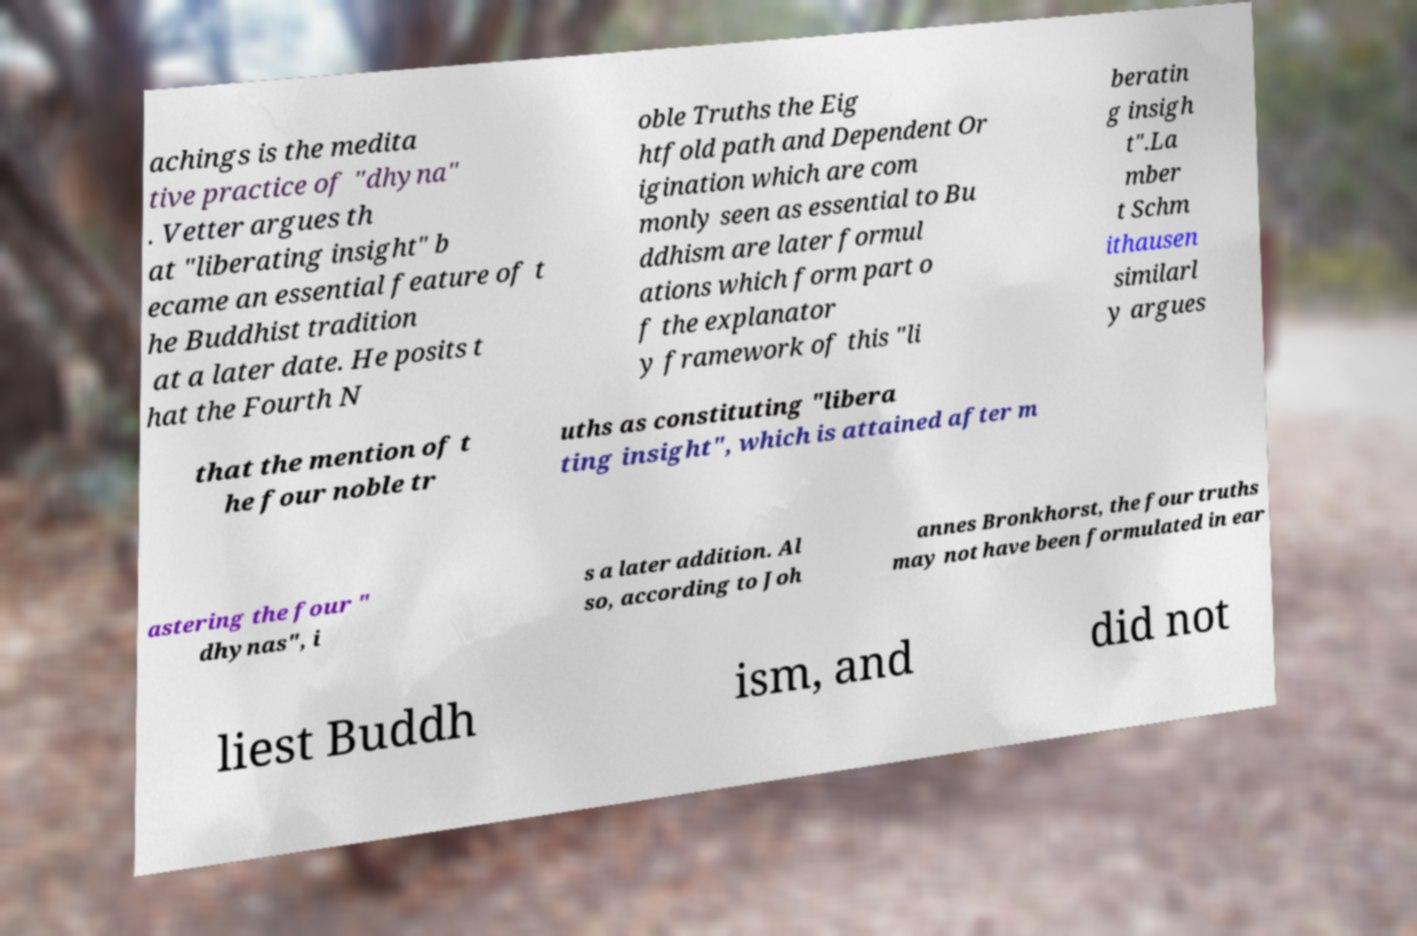Please read and relay the text visible in this image. What does it say? achings is the medita tive practice of "dhyna" . Vetter argues th at "liberating insight" b ecame an essential feature of t he Buddhist tradition at a later date. He posits t hat the Fourth N oble Truths the Eig htfold path and Dependent Or igination which are com monly seen as essential to Bu ddhism are later formul ations which form part o f the explanator y framework of this "li beratin g insigh t".La mber t Schm ithausen similarl y argues that the mention of t he four noble tr uths as constituting "libera ting insight", which is attained after m astering the four " dhynas", i s a later addition. Al so, according to Joh annes Bronkhorst, the four truths may not have been formulated in ear liest Buddh ism, and did not 